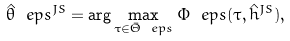Convert formula to latex. <formula><loc_0><loc_0><loc_500><loc_500>\hat { \theta } _ { \ } e p s ^ { J S } = \arg \max _ { \tau \in \bar { \Theta } _ { \ } e p s } \Phi _ { \ } e p s ( \tau , \hat { h } ^ { J S } ) ,</formula> 